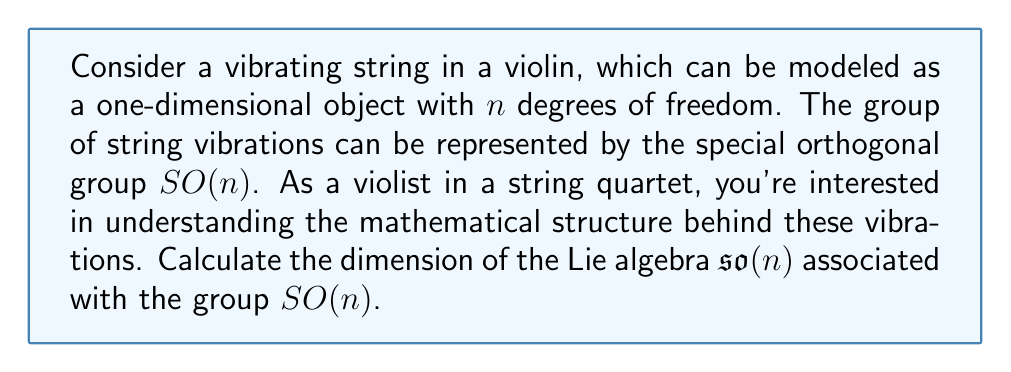Provide a solution to this math problem. To calculate the dimension of the Lie algebra $\mathfrak{so}(n)$, we can follow these steps:

1) The Lie algebra $\mathfrak{so}(n)$ consists of all $n \times n$ skew-symmetric matrices. A skew-symmetric matrix $A$ satisfies $A^T = -A$.

2) In a general $n \times n$ matrix, we have $n^2$ entries.

3) For a skew-symmetric matrix:
   - The diagonal elements must all be zero (because $a_{ii} = -a_{ii}$ implies $a_{ii} = 0$).
   - The elements below the diagonal determine the elements above the diagonal (because $a_{ij} = -a_{ji}$).

4) Therefore, we only need to count the number of elements below the diagonal.

5) The number of elements below the diagonal in an $n \times n$ matrix is:

   $$\frac{n(n-1)}{2}$$

   This can be derived by observing that the first row has 0 elements below it, the second row has 1, the third has 2, and so on up to the $n$-th row which has $n-1$ elements below it. This forms an arithmetic sequence with $n-1$ terms, starting at 0 and ending at $n-2$.

6) Thus, the dimension of $\mathfrak{so}(n)$ is $\frac{n(n-1)}{2}$.

This result tells us that as the number of degrees of freedom in our string model increases, the dimension of the associated Lie algebra grows quadratically. This reflects the increasing complexity of the possible vibrations in higher-dimensional models.
Answer: The dimension of the Lie algebra $\mathfrak{so}(n)$ associated with the group $SO(n)$ of string vibrations with $n$ degrees of freedom is $\frac{n(n-1)}{2}$. 